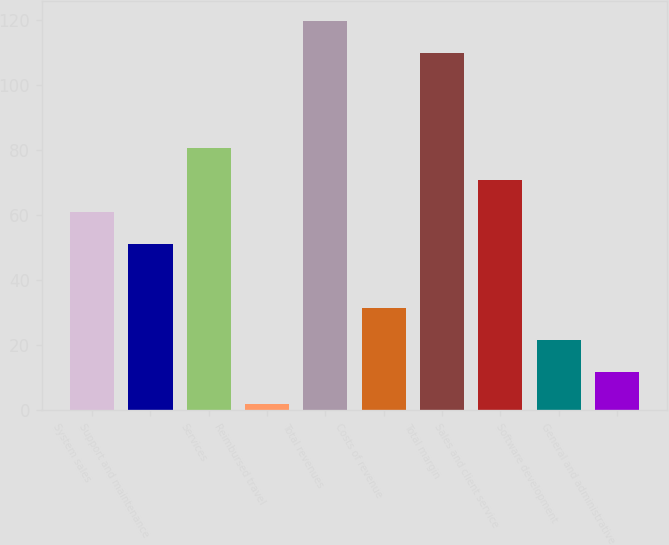Convert chart. <chart><loc_0><loc_0><loc_500><loc_500><bar_chart><fcel>System sales<fcel>Support and maintenance<fcel>Services<fcel>Reimbursed travel<fcel>Total revenues<fcel>Costs of revenue<fcel>Total margin<fcel>Sales and client service<fcel>Software development<fcel>General and administrative<nl><fcel>60.8<fcel>51<fcel>80.4<fcel>2<fcel>119.6<fcel>31.4<fcel>109.8<fcel>70.6<fcel>21.6<fcel>11.8<nl></chart> 